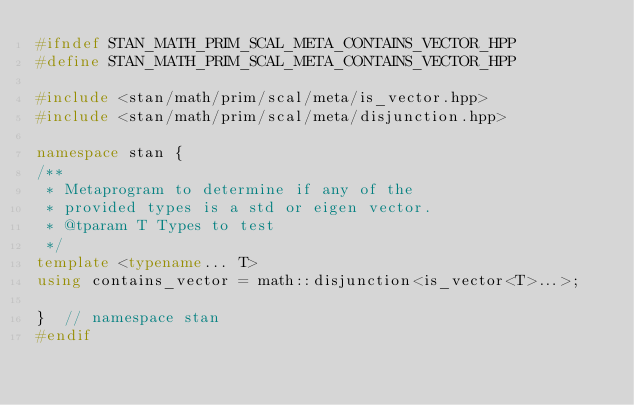<code> <loc_0><loc_0><loc_500><loc_500><_C++_>#ifndef STAN_MATH_PRIM_SCAL_META_CONTAINS_VECTOR_HPP
#define STAN_MATH_PRIM_SCAL_META_CONTAINS_VECTOR_HPP

#include <stan/math/prim/scal/meta/is_vector.hpp>
#include <stan/math/prim/scal/meta/disjunction.hpp>

namespace stan {
/**
 * Metaprogram to determine if any of the
 * provided types is a std or eigen vector.
 * @tparam T Types to test
 */
template <typename... T>
using contains_vector = math::disjunction<is_vector<T>...>;

}  // namespace stan
#endif
</code> 